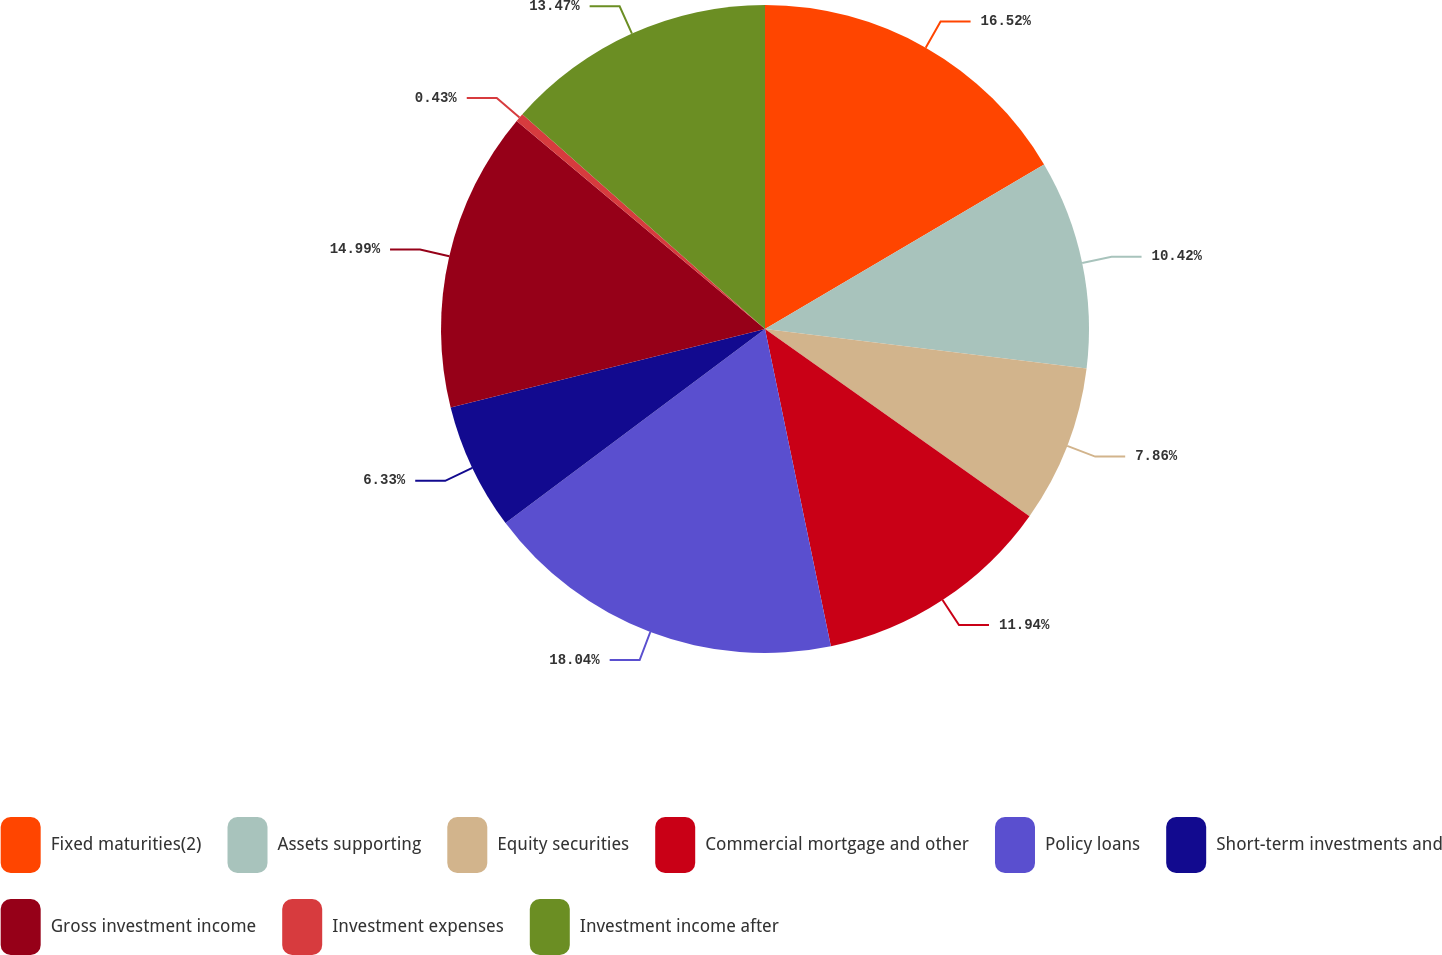<chart> <loc_0><loc_0><loc_500><loc_500><pie_chart><fcel>Fixed maturities(2)<fcel>Assets supporting<fcel>Equity securities<fcel>Commercial mortgage and other<fcel>Policy loans<fcel>Short-term investments and<fcel>Gross investment income<fcel>Investment expenses<fcel>Investment income after<nl><fcel>16.52%<fcel>10.42%<fcel>7.86%<fcel>11.94%<fcel>18.04%<fcel>6.33%<fcel>14.99%<fcel>0.43%<fcel>13.47%<nl></chart> 